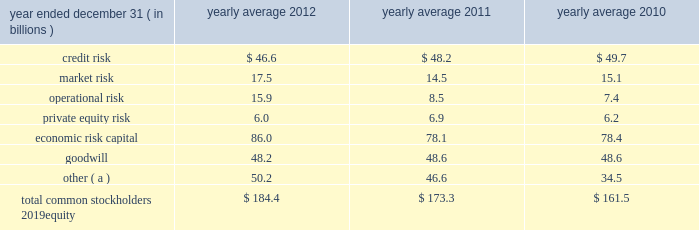Management 2019s discussion and analysis 120 jpmorgan chase & co./2012 annual report $ 12.0 billion , and jpmorgan clearing 2019s net capital was $ 6.6 billion , exceeding the minimum requirement by $ 5.0 billion .
In addition to its minimum net capital requirement , jpmorgan securities is required to hold tentative net capital in excess of $ 1.0 billion and is also required to notify the sec in the event that tentative net capital is less than $ 5.0 billion , in accordance with the market and credit risk standards of appendix e of the net capital rule .
As of december 31 , 2012 , jpmorgan securities had tentative net capital in excess of the minimum and notification requirements .
J.p .
Morgan securities plc ( formerly j.p .
Morgan securities ltd. ) is a wholly-owned subsidiary of jpmorgan chase bank , n.a .
And is the firm 2019s principal operating subsidiary in the u.k .
It has authority to engage in banking , investment banking and broker-dealer activities .
J.p .
Morgan securities plc is regulated by the u.k .
Financial services authority ( 201cfsa 201d ) .
At december 31 , 2012 , it had total capital of $ 20.8 billion , or a total capital ratio of 15.5% ( 15.5 % ) which exceeded the 8% ( 8 % ) well-capitalized standard applicable to it under basel 2.5 .
Economic risk capital jpmorgan chase assesses its capital adequacy relative to the risks underlying its business activities using internal risk-assessment methodologies .
The firm measures economic capital primarily based on four risk factors : credit , market , operational and private equity risk. .
( a ) reflects additional capital required , in the firm 2019s view , to meet its regulatory and debt rating objectives .
Credit risk capital credit risk capital is estimated separately for the wholesale businesses ( cib , cb and am ) and consumer business ( ccb ) .
Credit risk capital for the wholesale credit portfolio is defined in terms of unexpected credit losses , both from defaults and from declines in the value of the portfolio due to credit deterioration , measured over a one-year period at a confidence level consistent with an 201caa 201d credit rating standard .
Unexpected losses are losses in excess of those for which the allowance for credit losses is maintained .
The capital methodology is based on several principal drivers of credit risk : exposure at default ( or loan-equivalent amount ) , default likelihood , credit spreads , loss severity and portfolio correlation .
Credit risk capital for the consumer portfolio is based on product and other relevant risk segmentation .
Actual segment-level default and severity experience are used to estimate unexpected losses for a one-year horizon at a confidence level consistent with an 201caa 201d credit rating standard .
The decrease in credit risk capital in 2012 was driven by consumer portfolio runoff and continued model enhancements to better estimate future stress credit losses in the consumer portfolio .
See credit risk management on pages 134 2013135 of this annual report for more information about these credit risk measures .
Market risk capital the firm calculates market risk capital guided by the principle that capital should reflect the risk of loss in the value of the portfolios and financial instruments caused by adverse movements in market variables , such as interest and foreign exchange rates , credit spreads , and securities and commodities prices , taking into account the liquidity of the financial instruments .
Results from daily var , weekly stress tests , issuer credit spreads and default risk calculations , as well as other factors , are used to determine appropriate capital levels .
Market risk capital is allocated to each business segment based on its risk assessment .
The increase in market risk capital in 2012 was driven by increased risk in the synthetic credit portfolio .
See market risk management on pages 163 2013169 of this annual report for more information about these market risk measures .
Operational risk capital operational risk is the risk of loss resulting from inadequate or failed processes or systems , human factors or external events .
The operational risk capital model is based on actual losses and potential scenario-based losses , with adjustments to the capital calculation to reflect changes in the quality of the control environment .
The increase in operational risk capital in 2012 was primarily due to continued model enhancements to better capture large historical loss events , including mortgage-related litigation costs .
The increases that occurred during 2012 will be fully reflected in average operational risk capital in 2013 .
See operational risk management on pages 175 2013176 of this annual report for more information about operational risk .
Private equity risk capital capital is allocated to privately- and publicly-held securities , third-party fund investments , and commitments in the private equity portfolio , within the corporate/private equity segment , to cover the potential loss associated with a decline in equity markets and related asset devaluations .
In addition to negative market fluctuations , potential losses in private equity investment portfolios can be magnified by liquidity risk. .
In comparing 2010 and 2012 figures , how much additional capital , in percentage , is required in 2012 for the firm to meet regulatory and debt obligations? 
Rationale: 34.5*x=50.2
Computations: (50.2 / 34.5)
Answer: 1.45507. 